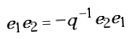Convert formula to latex. <formula><loc_0><loc_0><loc_500><loc_500>e _ { 1 } e _ { 2 } = - q ^ { - 1 } e _ { 2 } e _ { 1 }</formula> 